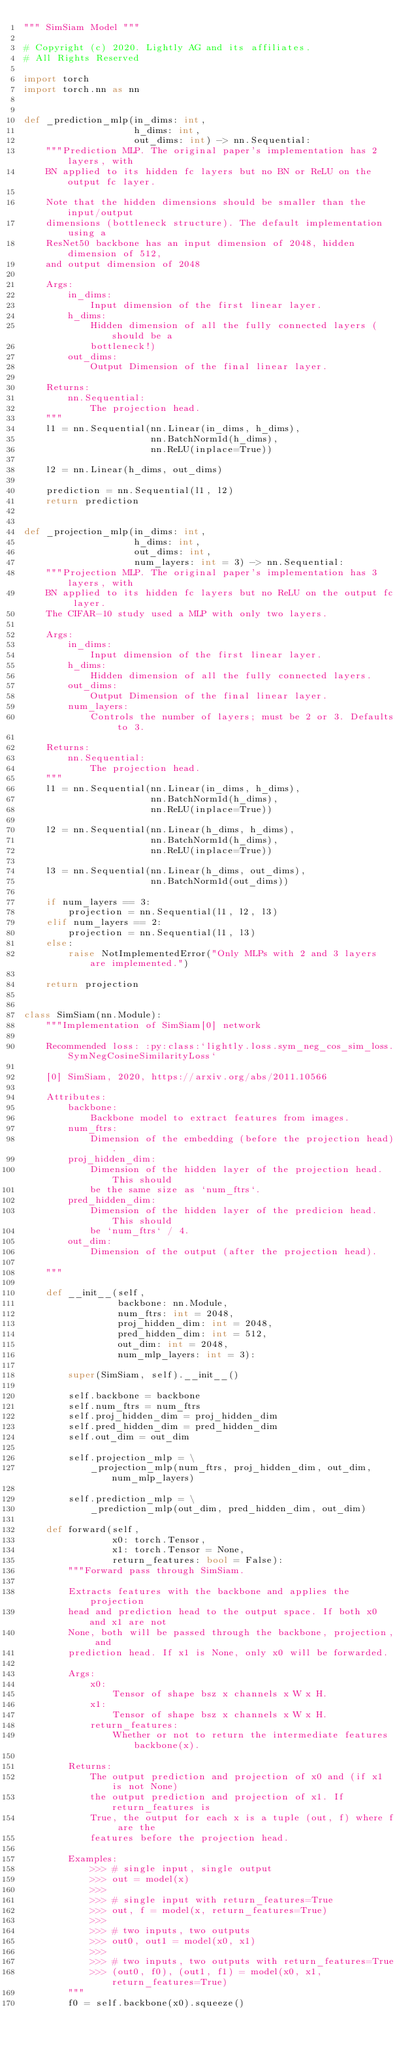<code> <loc_0><loc_0><loc_500><loc_500><_Python_>""" SimSiam Model """

# Copyright (c) 2020. Lightly AG and its affiliates.
# All Rights Reserved

import torch
import torch.nn as nn


def _prediction_mlp(in_dims: int, 
                    h_dims: int, 
                    out_dims: int) -> nn.Sequential:
    """Prediction MLP. The original paper's implementation has 2 layers, with 
    BN applied to its hidden fc layers but no BN or ReLU on the output fc layer.

    Note that the hidden dimensions should be smaller than the input/output 
    dimensions (bottleneck structure). The default implementation using a 
    ResNet50 backbone has an input dimension of 2048, hidden dimension of 512, 
    and output dimension of 2048

    Args:
        in_dims:
            Input dimension of the first linear layer.
        h_dims: 
            Hidden dimension of all the fully connected layers (should be a
            bottleneck!)
        out_dims: 
            Output Dimension of the final linear layer.

    Returns:
        nn.Sequential:
            The projection head.
    """
    l1 = nn.Sequential(nn.Linear(in_dims, h_dims),
                       nn.BatchNorm1d(h_dims),
                       nn.ReLU(inplace=True))

    l2 = nn.Linear(h_dims, out_dims)

    prediction = nn.Sequential(l1, l2)
    return prediction


def _projection_mlp(in_dims: int,
                    h_dims: int,
                    out_dims: int,
                    num_layers: int = 3) -> nn.Sequential:
    """Projection MLP. The original paper's implementation has 3 layers, with 
    BN applied to its hidden fc layers but no ReLU on the output fc layer. 
    The CIFAR-10 study used a MLP with only two layers.

    Args:
        in_dims:
            Input dimension of the first linear layer.
        h_dims: 
            Hidden dimension of all the fully connected layers.
        out_dims: 
            Output Dimension of the final linear layer.
        num_layers:
            Controls the number of layers; must be 2 or 3. Defaults to 3.

    Returns:
        nn.Sequential:
            The projection head.
    """
    l1 = nn.Sequential(nn.Linear(in_dims, h_dims),
                       nn.BatchNorm1d(h_dims),
                       nn.ReLU(inplace=True))

    l2 = nn.Sequential(nn.Linear(h_dims, h_dims),
                       nn.BatchNorm1d(h_dims),
                       nn.ReLU(inplace=True))

    l3 = nn.Sequential(nn.Linear(h_dims, out_dims),
                       nn.BatchNorm1d(out_dims))

    if num_layers == 3:
        projection = nn.Sequential(l1, l2, l3)
    elif num_layers == 2:
        projection = nn.Sequential(l1, l3)
    else:
        raise NotImplementedError("Only MLPs with 2 and 3 layers are implemented.")

    return projection


class SimSiam(nn.Module):
    """Implementation of SimSiam[0] network

    Recommended loss: :py:class:`lightly.loss.sym_neg_cos_sim_loss.SymNegCosineSimilarityLoss`

    [0] SimSiam, 2020, https://arxiv.org/abs/2011.10566

    Attributes:
        backbone:
            Backbone model to extract features from images.
        num_ftrs:
            Dimension of the embedding (before the projection head).
        proj_hidden_dim:
            Dimension of the hidden layer of the projection head. This should
            be the same size as `num_ftrs`.
        pred_hidden_dim:
            Dimension of the hidden layer of the predicion head. This should
            be `num_ftrs` / 4.
        out_dim:
            Dimension of the output (after the projection head).

    """

    def __init__(self,
                 backbone: nn.Module,
                 num_ftrs: int = 2048,
                 proj_hidden_dim: int = 2048,
                 pred_hidden_dim: int = 512,
                 out_dim: int = 2048,
                 num_mlp_layers: int = 3):

        super(SimSiam, self).__init__()

        self.backbone = backbone
        self.num_ftrs = num_ftrs
        self.proj_hidden_dim = proj_hidden_dim
        self.pred_hidden_dim = pred_hidden_dim
        self.out_dim = out_dim

        self.projection_mlp = \
            _projection_mlp(num_ftrs, proj_hidden_dim, out_dim, num_mlp_layers)

        self.prediction_mlp = \
            _prediction_mlp(out_dim, pred_hidden_dim, out_dim)
        
    def forward(self, 
                x0: torch.Tensor, 
                x1: torch.Tensor = None,
                return_features: bool = False):
        """Forward pass through SimSiam.

        Extracts features with the backbone and applies the projection
        head and prediction head to the output space. If both x0 and x1 are not
        None, both will be passed through the backbone, projection, and
        prediction head. If x1 is None, only x0 will be forwarded.

        Args:
            x0:
                Tensor of shape bsz x channels x W x H.
            x1:
                Tensor of shape bsz x channels x W x H.
            return_features:
                Whether or not to return the intermediate features backbone(x).

        Returns:
            The output prediction and projection of x0 and (if x1 is not None)
            the output prediction and projection of x1. If return_features is
            True, the output for each x is a tuple (out, f) where f are the
            features before the projection head.
            
        Examples:
            >>> # single input, single output
            >>> out = model(x) 
            >>> 
            >>> # single input with return_features=True
            >>> out, f = model(x, return_features=True)
            >>>
            >>> # two inputs, two outputs
            >>> out0, out1 = model(x0, x1)
            >>>
            >>> # two inputs, two outputs with return_features=True
            >>> (out0, f0), (out1, f1) = model(x0, x1, return_features=True)
        """
        f0 = self.backbone(x0).squeeze()</code> 